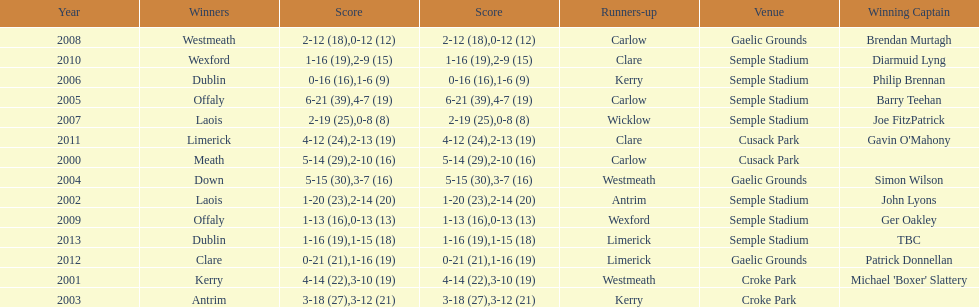How many winners won in semple stadium? 7. 